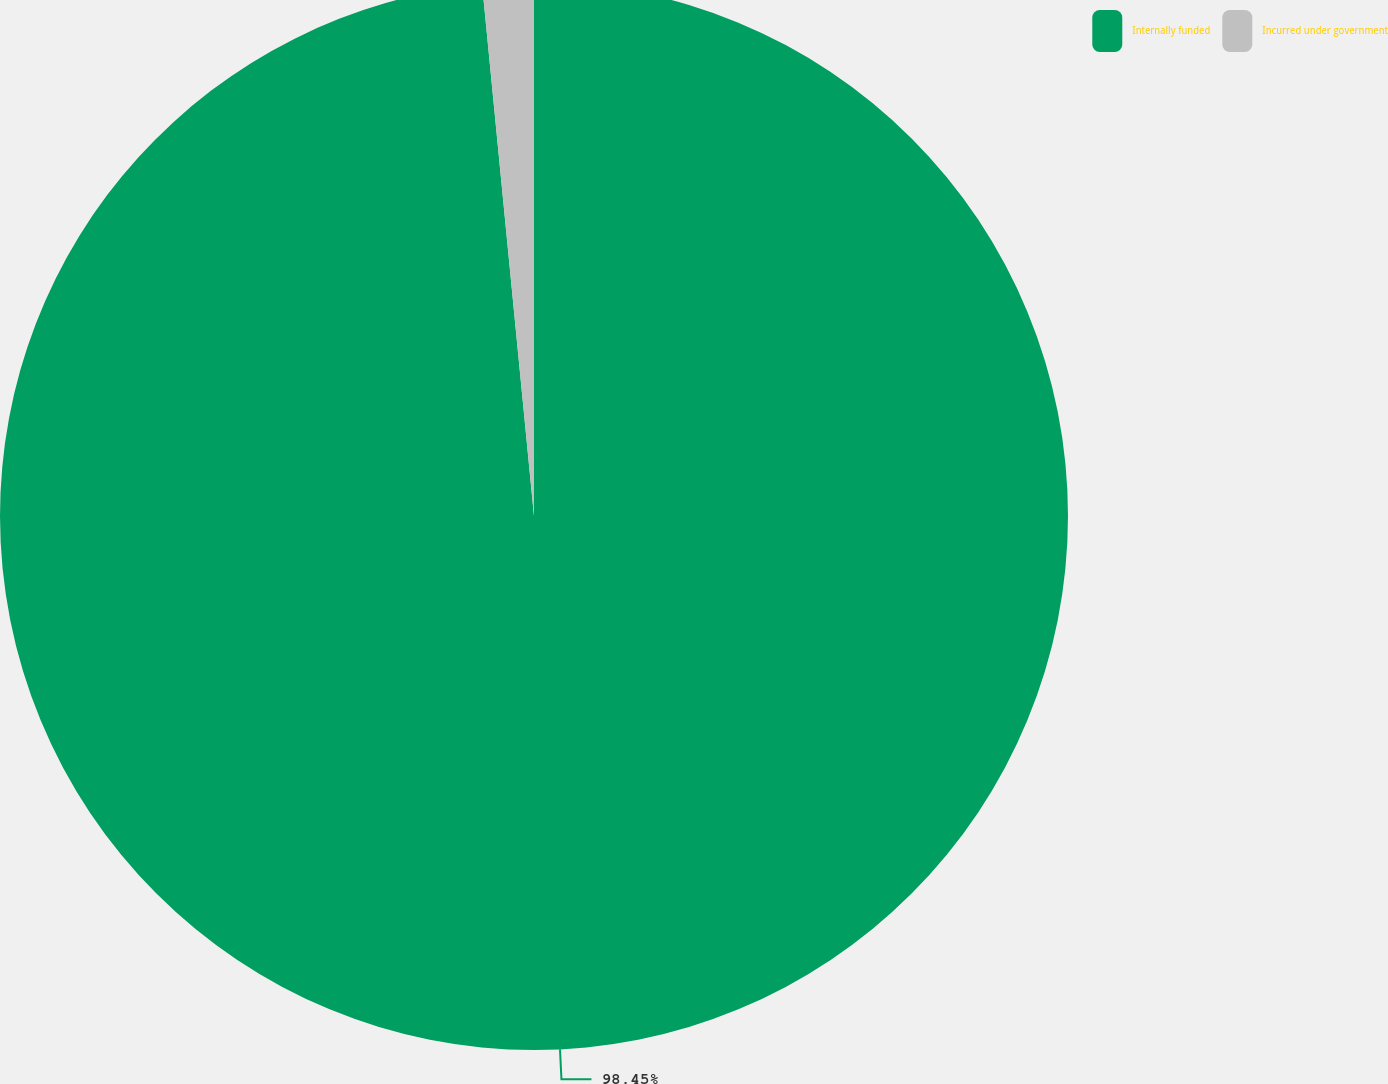<chart> <loc_0><loc_0><loc_500><loc_500><pie_chart><fcel>Internally funded<fcel>Incurred under government<nl><fcel>98.45%<fcel>1.55%<nl></chart> 